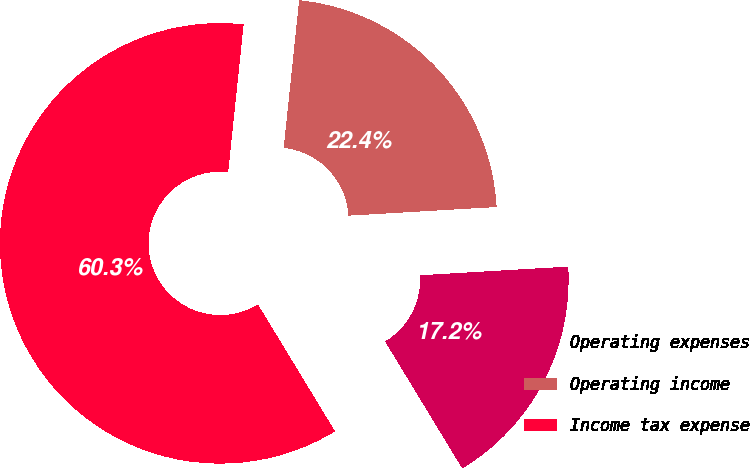<chart> <loc_0><loc_0><loc_500><loc_500><pie_chart><fcel>Operating expenses<fcel>Operating income<fcel>Income tax expense<nl><fcel>17.24%<fcel>22.41%<fcel>60.34%<nl></chart> 